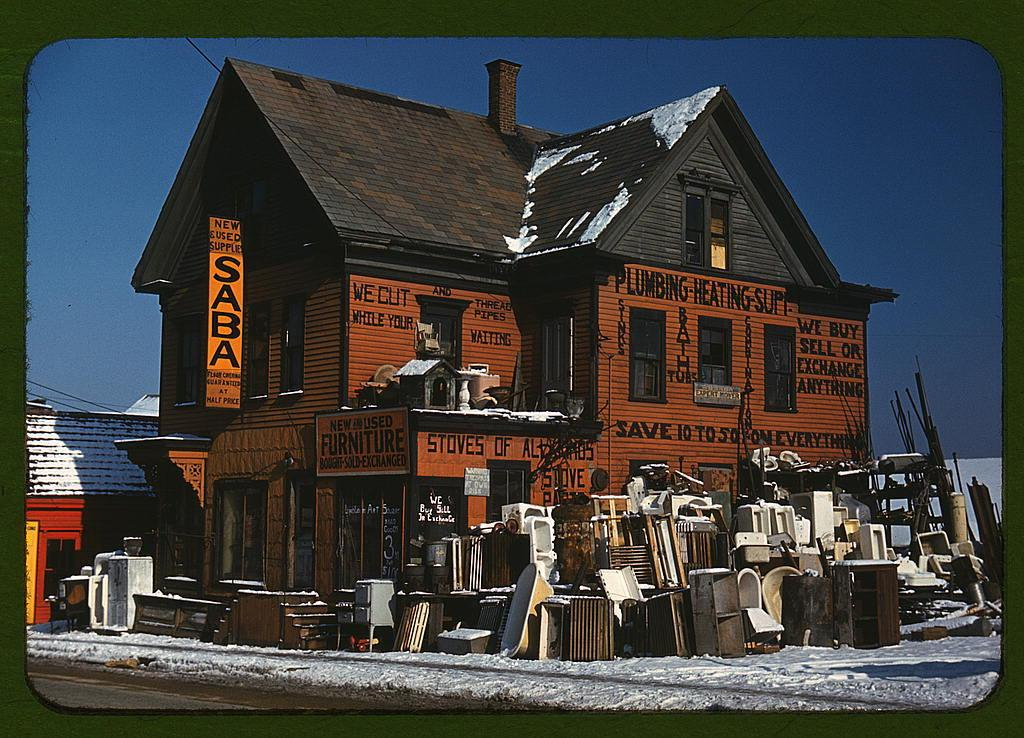What type of structures can be seen in the image? There are houses in the image. What else is present on the boards with text? The boards with text are not described in detail, so we cannot determine what else is present on them. What can be seen on the ground in the image? The ground is visible in the image with some objects, but the specific objects are not mentioned. What is the weather like in the image? The presence of snow in the image suggests that it is a snowy or winter scene. What else can be seen in the image besides the houses and boards with text? There are wires and the sky visible in the image. What type of cabbage is being shaken in the image? There is no cabbage or shaking activity present in the image. How many people are walking in the image? The image does not depict any people walking; it primarily features houses, boards with text, snow, wires, and the sky. 